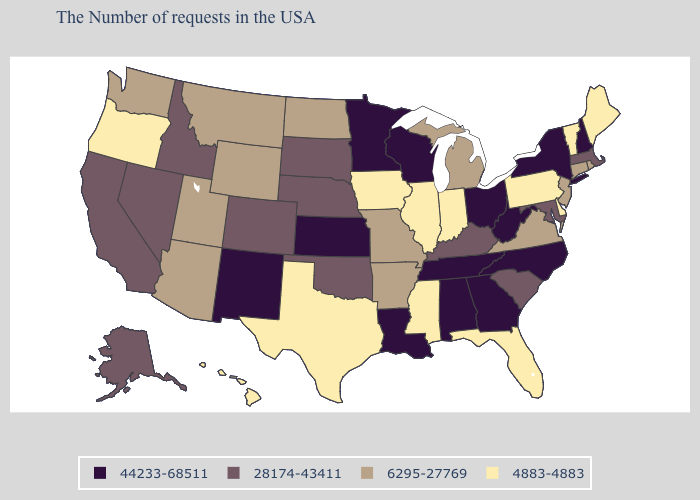Does Nevada have a higher value than South Dakota?
Be succinct. No. What is the highest value in the USA?
Write a very short answer. 44233-68511. What is the lowest value in states that border Arkansas?
Answer briefly. 4883-4883. What is the value of West Virginia?
Short answer required. 44233-68511. Does Wyoming have the highest value in the West?
Write a very short answer. No. Name the states that have a value in the range 44233-68511?
Answer briefly. New Hampshire, New York, North Carolina, West Virginia, Ohio, Georgia, Alabama, Tennessee, Wisconsin, Louisiana, Minnesota, Kansas, New Mexico. Among the states that border Oklahoma , does Kansas have the lowest value?
Answer briefly. No. Name the states that have a value in the range 6295-27769?
Keep it brief. Rhode Island, Connecticut, New Jersey, Virginia, Michigan, Missouri, Arkansas, North Dakota, Wyoming, Utah, Montana, Arizona, Washington. Which states hav the highest value in the MidWest?
Answer briefly. Ohio, Wisconsin, Minnesota, Kansas. Does New Jersey have the highest value in the USA?
Short answer required. No. Does the first symbol in the legend represent the smallest category?
Answer briefly. No. How many symbols are there in the legend?
Keep it brief. 4. Name the states that have a value in the range 6295-27769?
Write a very short answer. Rhode Island, Connecticut, New Jersey, Virginia, Michigan, Missouri, Arkansas, North Dakota, Wyoming, Utah, Montana, Arizona, Washington. What is the value of Mississippi?
Write a very short answer. 4883-4883. Among the states that border Nebraska , does Colorado have the lowest value?
Give a very brief answer. No. 